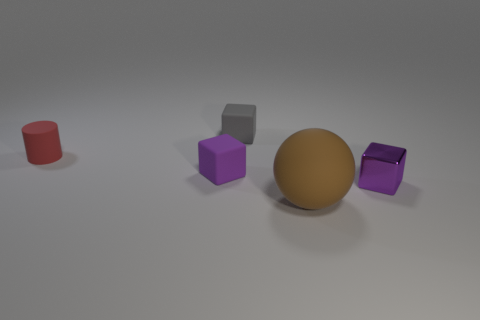Subtract all purple cylinders. How many purple cubes are left? 2 Subtract all purple blocks. How many blocks are left? 1 Add 5 small cubes. How many objects exist? 10 Subtract all yellow blocks. Subtract all yellow cylinders. How many blocks are left? 3 Subtract all blocks. How many objects are left? 2 Subtract all blocks. Subtract all gray cubes. How many objects are left? 1 Add 4 tiny gray matte objects. How many tiny gray matte objects are left? 5 Add 5 large gray matte things. How many large gray matte things exist? 5 Subtract 0 cyan cylinders. How many objects are left? 5 